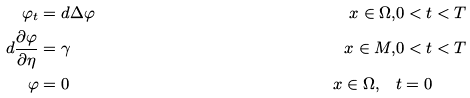<formula> <loc_0><loc_0><loc_500><loc_500>\varphi _ { t } & = d \Delta \varphi & x \in \Omega , & 0 < t < T \\ d \frac { \partial \varphi } { \partial \eta } & = \gamma & x \in M , & 0 < t < T \\ \varphi & = 0 & x \in \Omega , \quad & t = 0</formula> 